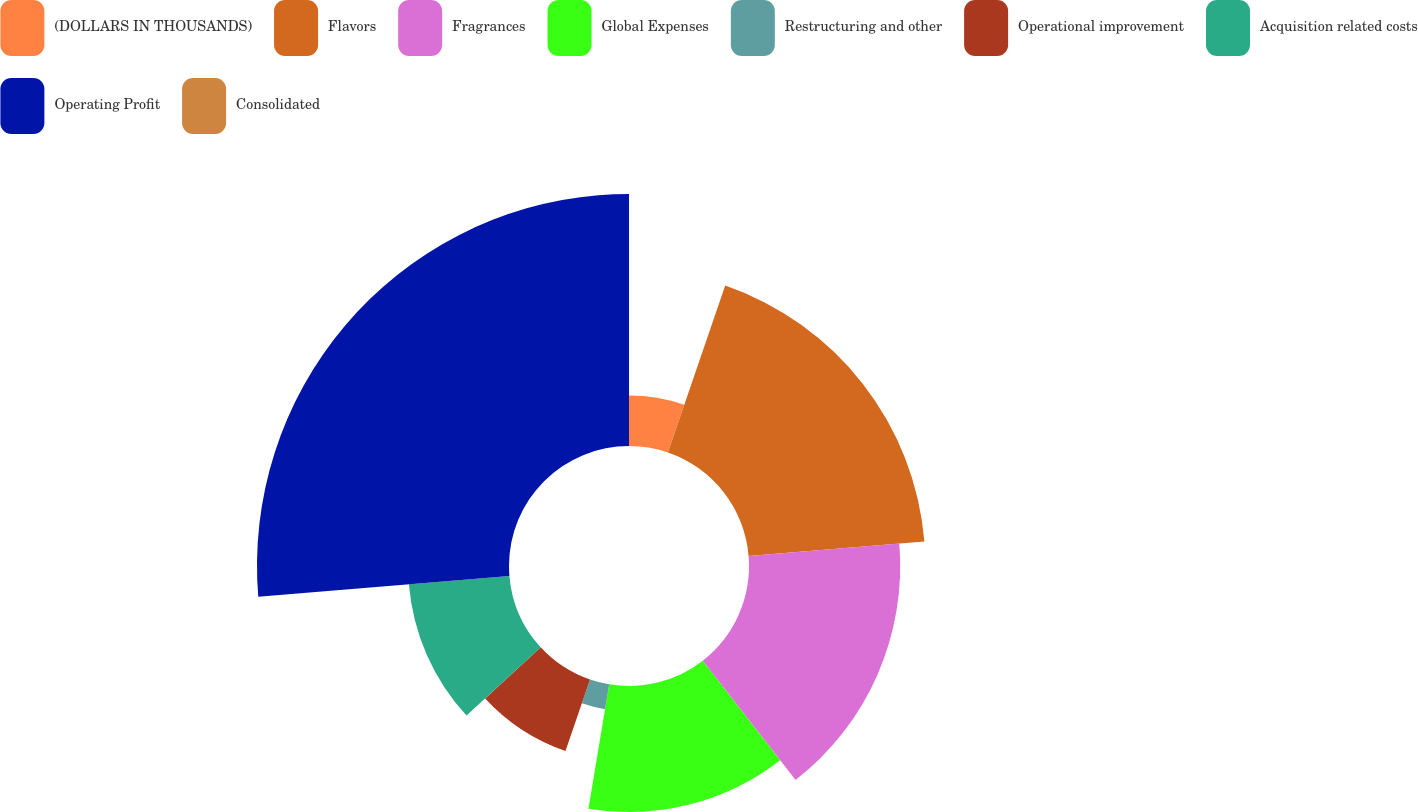Convert chart to OTSL. <chart><loc_0><loc_0><loc_500><loc_500><pie_chart><fcel>(DOLLARS IN THOUSANDS)<fcel>Flavors<fcel>Fragrances<fcel>Global Expenses<fcel>Restructuring and other<fcel>Operational improvement<fcel>Acquisition related costs<fcel>Operating Profit<fcel>Consolidated<nl><fcel>5.26%<fcel>18.42%<fcel>15.79%<fcel>13.16%<fcel>2.63%<fcel>7.89%<fcel>10.53%<fcel>26.31%<fcel>0.0%<nl></chart> 